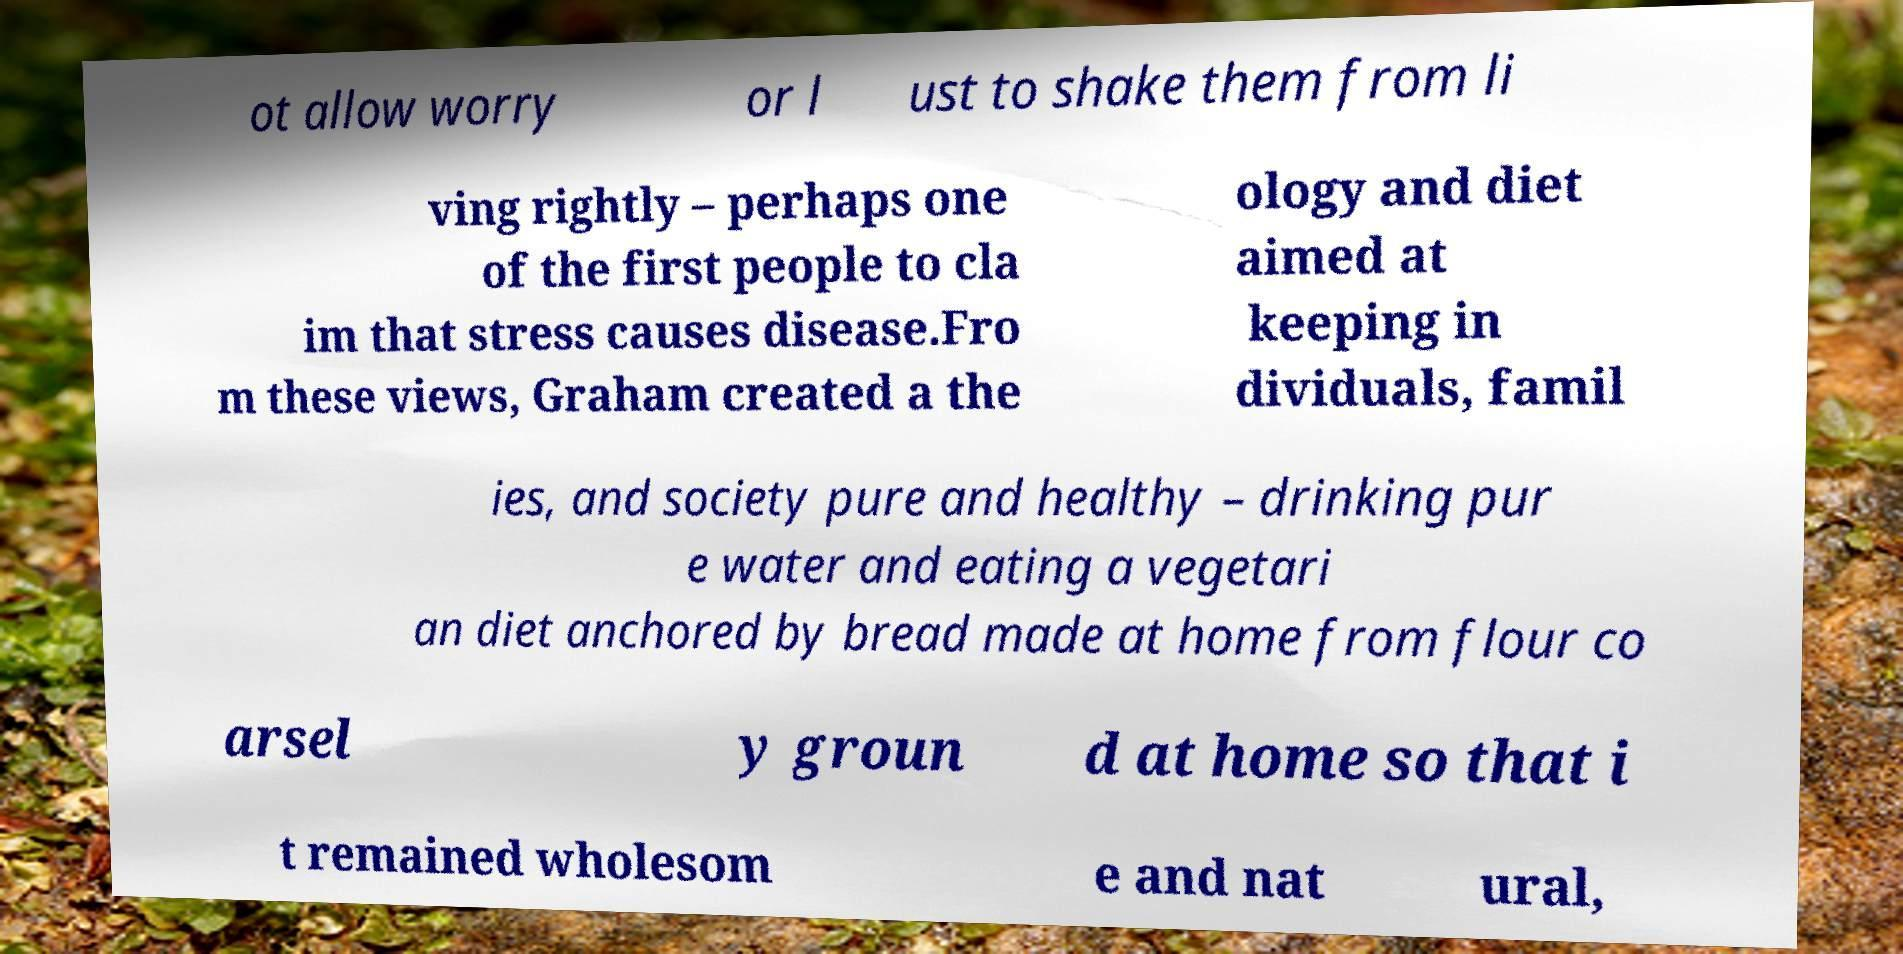Can you read and provide the text displayed in the image?This photo seems to have some interesting text. Can you extract and type it out for me? ot allow worry or l ust to shake them from li ving rightly – perhaps one of the first people to cla im that stress causes disease.Fro m these views, Graham created a the ology and diet aimed at keeping in dividuals, famil ies, and society pure and healthy – drinking pur e water and eating a vegetari an diet anchored by bread made at home from flour co arsel y groun d at home so that i t remained wholesom e and nat ural, 